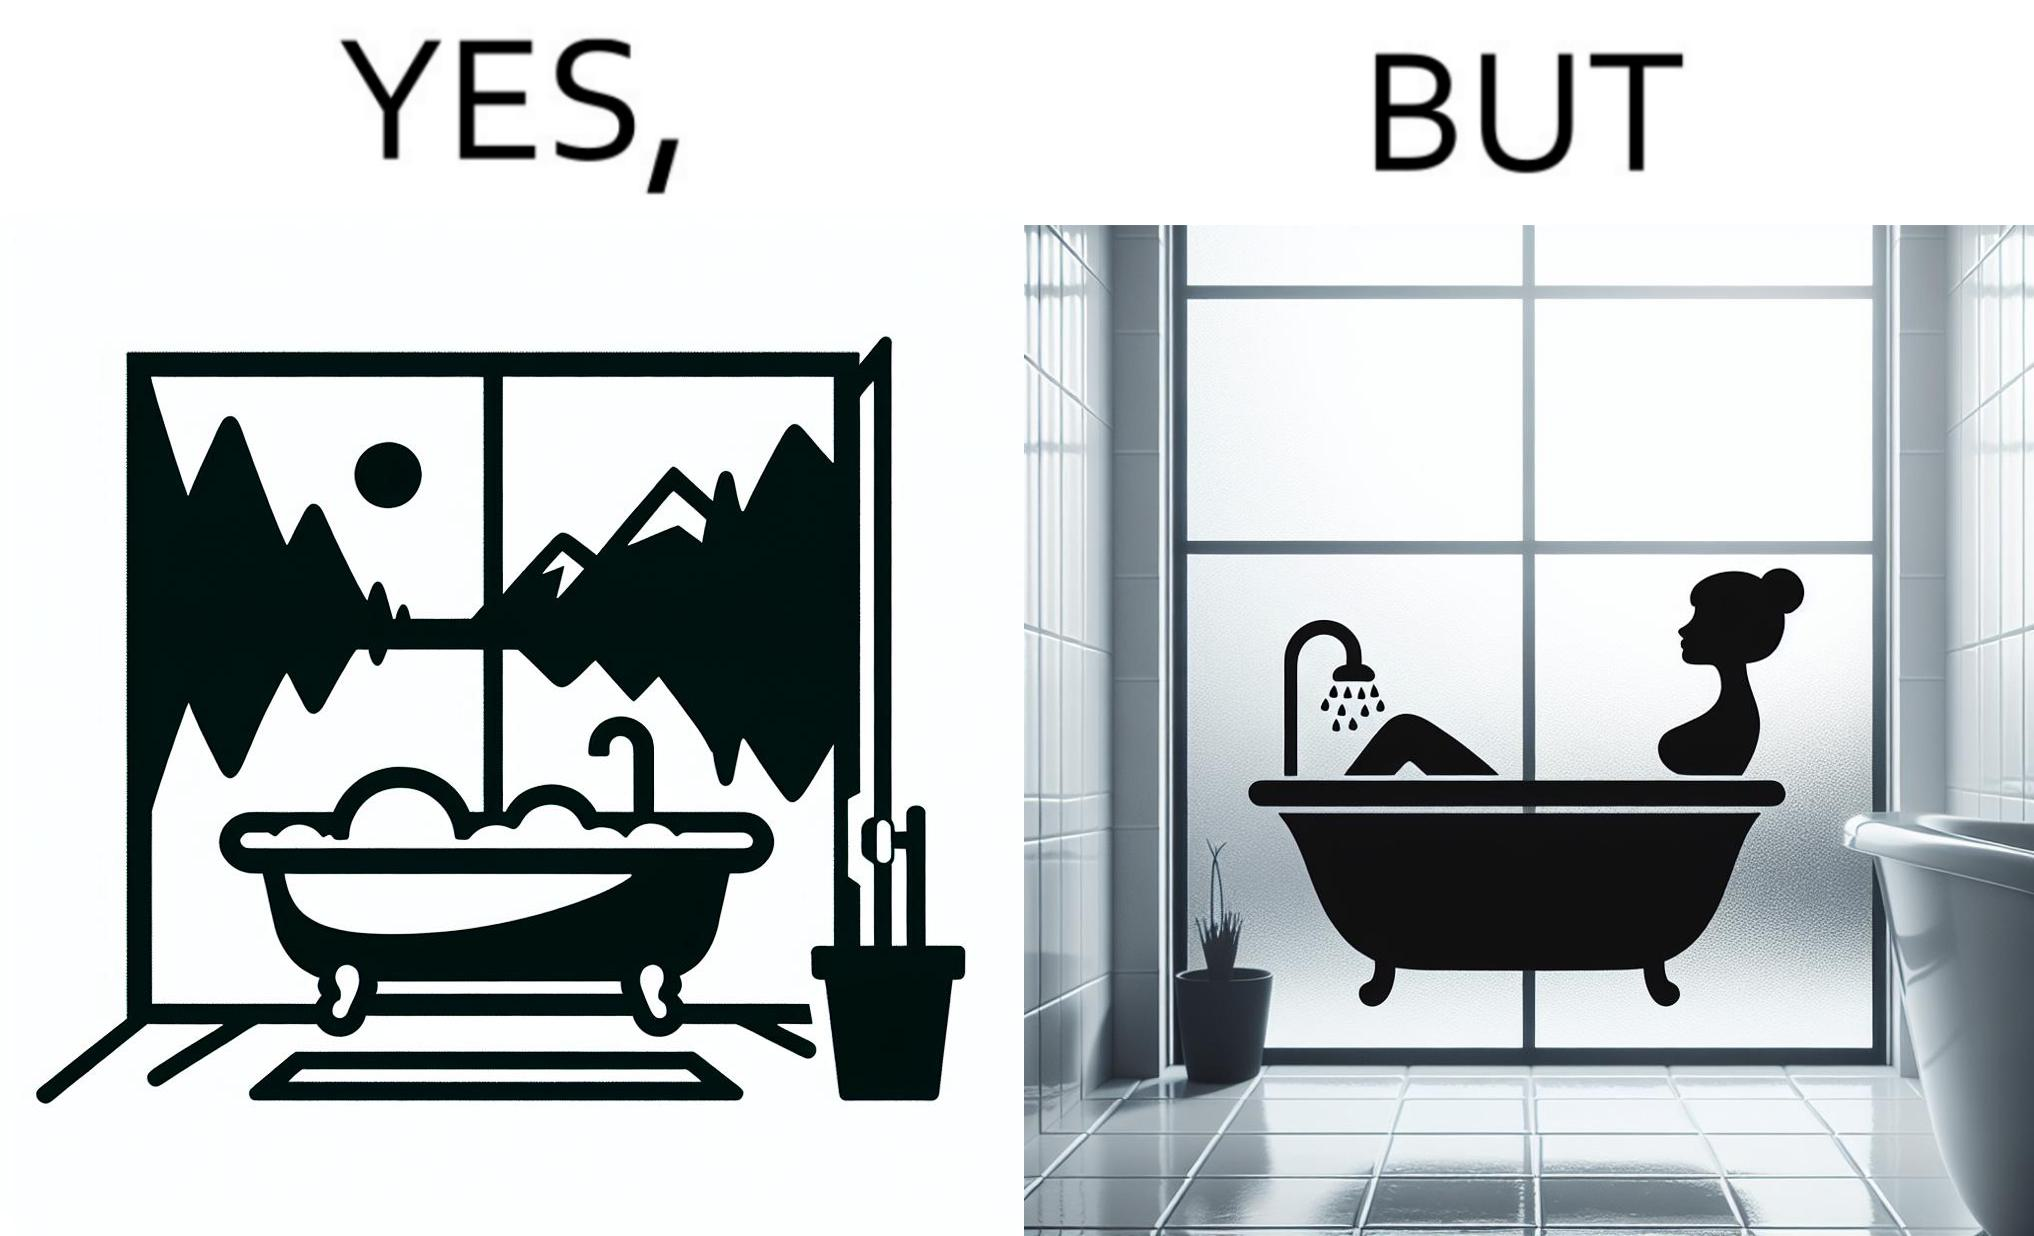Describe what you see in this image. The image is ironical, as a bathtub near a window having a very scenic view, becomes misty when someone is bathing, thus making the scenic view blurry. 